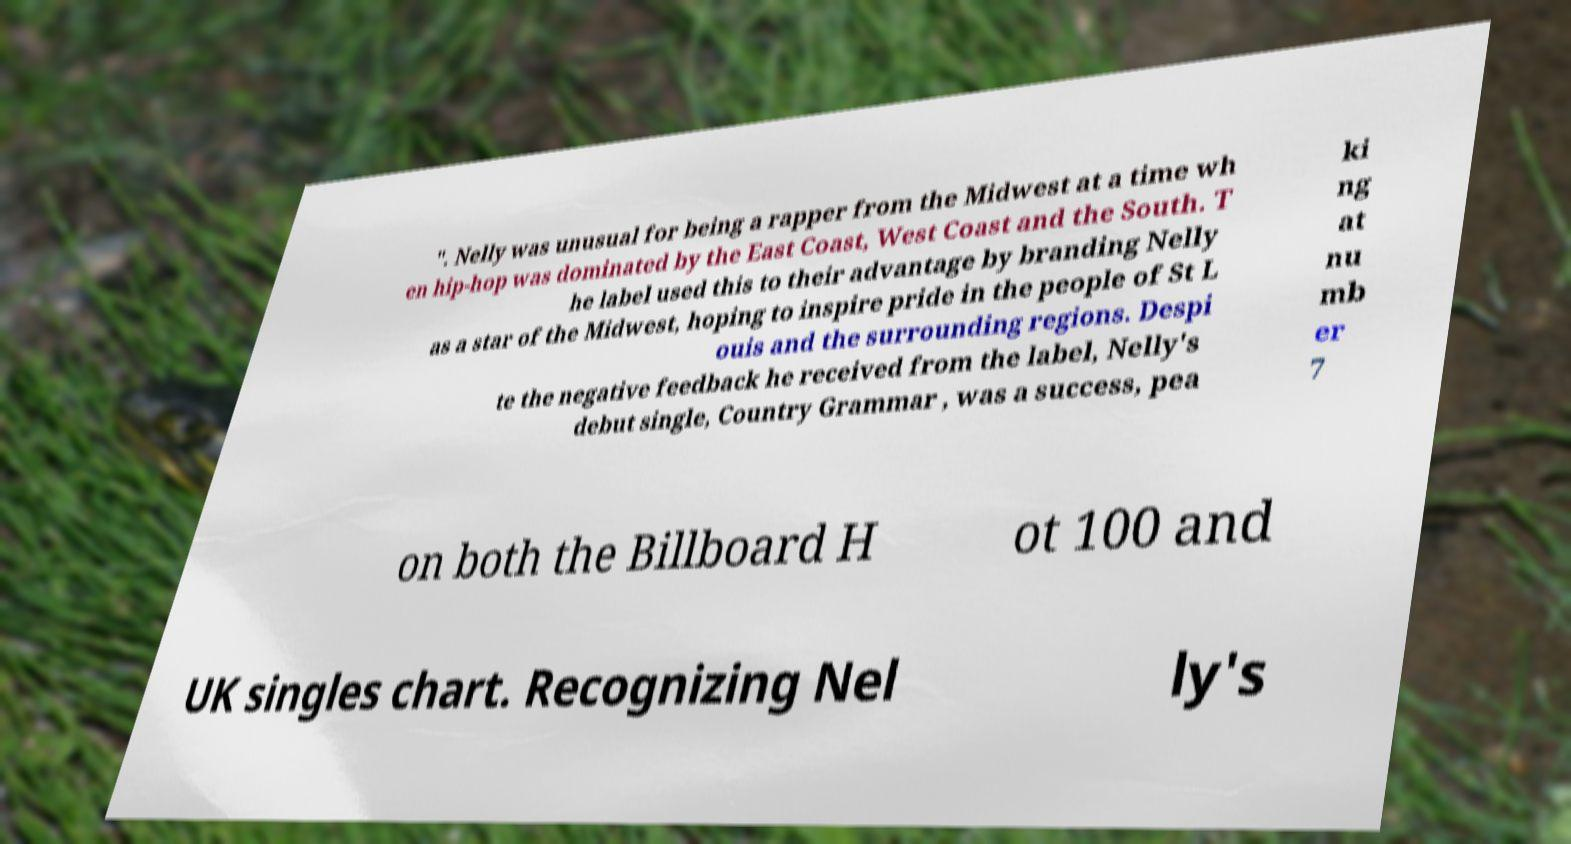Can you read and provide the text displayed in the image?This photo seems to have some interesting text. Can you extract and type it out for me? ". Nelly was unusual for being a rapper from the Midwest at a time wh en hip-hop was dominated by the East Coast, West Coast and the South. T he label used this to their advantage by branding Nelly as a star of the Midwest, hoping to inspire pride in the people of St L ouis and the surrounding regions. Despi te the negative feedback he received from the label, Nelly's debut single, Country Grammar , was a success, pea ki ng at nu mb er 7 on both the Billboard H ot 100 and UK singles chart. Recognizing Nel ly's 